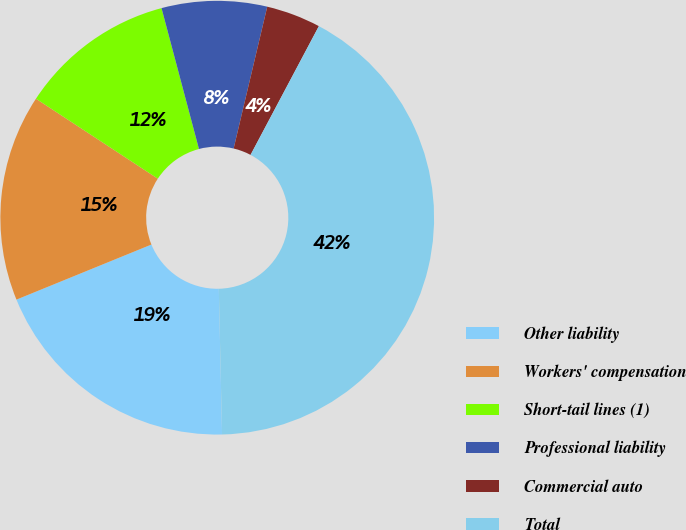Convert chart. <chart><loc_0><loc_0><loc_500><loc_500><pie_chart><fcel>Other liability<fcel>Workers' compensation<fcel>Short-tail lines (1)<fcel>Professional liability<fcel>Commercial auto<fcel>Total<nl><fcel>19.19%<fcel>15.41%<fcel>11.62%<fcel>7.84%<fcel>4.06%<fcel>41.88%<nl></chart> 